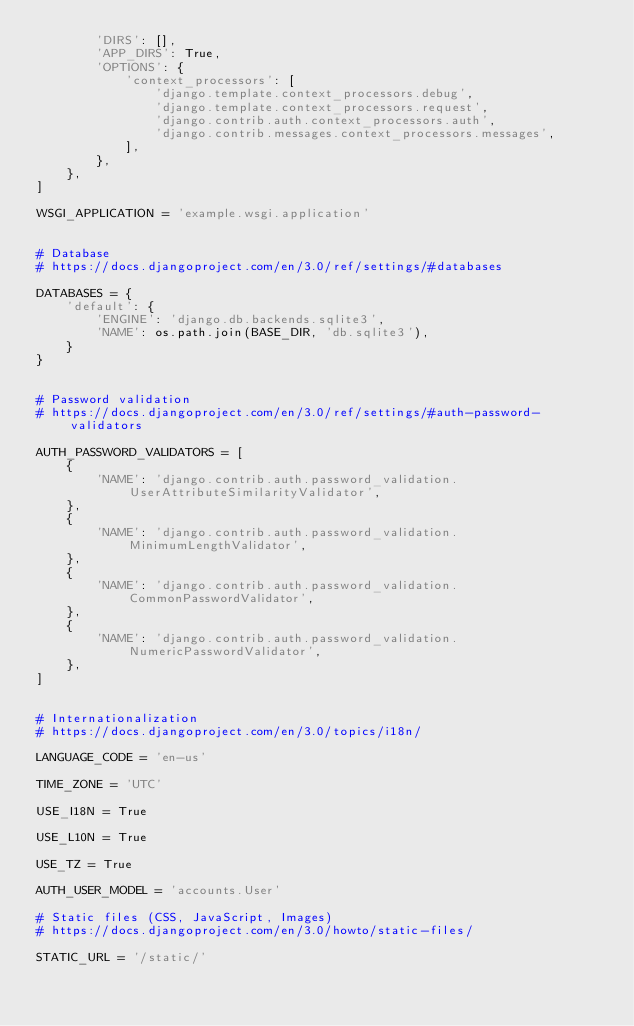<code> <loc_0><loc_0><loc_500><loc_500><_Python_>        'DIRS': [],
        'APP_DIRS': True,
        'OPTIONS': {
            'context_processors': [
                'django.template.context_processors.debug',
                'django.template.context_processors.request',
                'django.contrib.auth.context_processors.auth',
                'django.contrib.messages.context_processors.messages',
            ],
        },
    },
]

WSGI_APPLICATION = 'example.wsgi.application'


# Database
# https://docs.djangoproject.com/en/3.0/ref/settings/#databases

DATABASES = {
    'default': {
        'ENGINE': 'django.db.backends.sqlite3',
        'NAME': os.path.join(BASE_DIR, 'db.sqlite3'),
    }
}


# Password validation
# https://docs.djangoproject.com/en/3.0/ref/settings/#auth-password-validators

AUTH_PASSWORD_VALIDATORS = [
    {
        'NAME': 'django.contrib.auth.password_validation.UserAttributeSimilarityValidator',
    },
    {
        'NAME': 'django.contrib.auth.password_validation.MinimumLengthValidator',
    },
    {
        'NAME': 'django.contrib.auth.password_validation.CommonPasswordValidator',
    },
    {
        'NAME': 'django.contrib.auth.password_validation.NumericPasswordValidator',
    },
]


# Internationalization
# https://docs.djangoproject.com/en/3.0/topics/i18n/

LANGUAGE_CODE = 'en-us'

TIME_ZONE = 'UTC'

USE_I18N = True

USE_L10N = True

USE_TZ = True

AUTH_USER_MODEL = 'accounts.User'

# Static files (CSS, JavaScript, Images)
# https://docs.djangoproject.com/en/3.0/howto/static-files/

STATIC_URL = '/static/'
</code> 